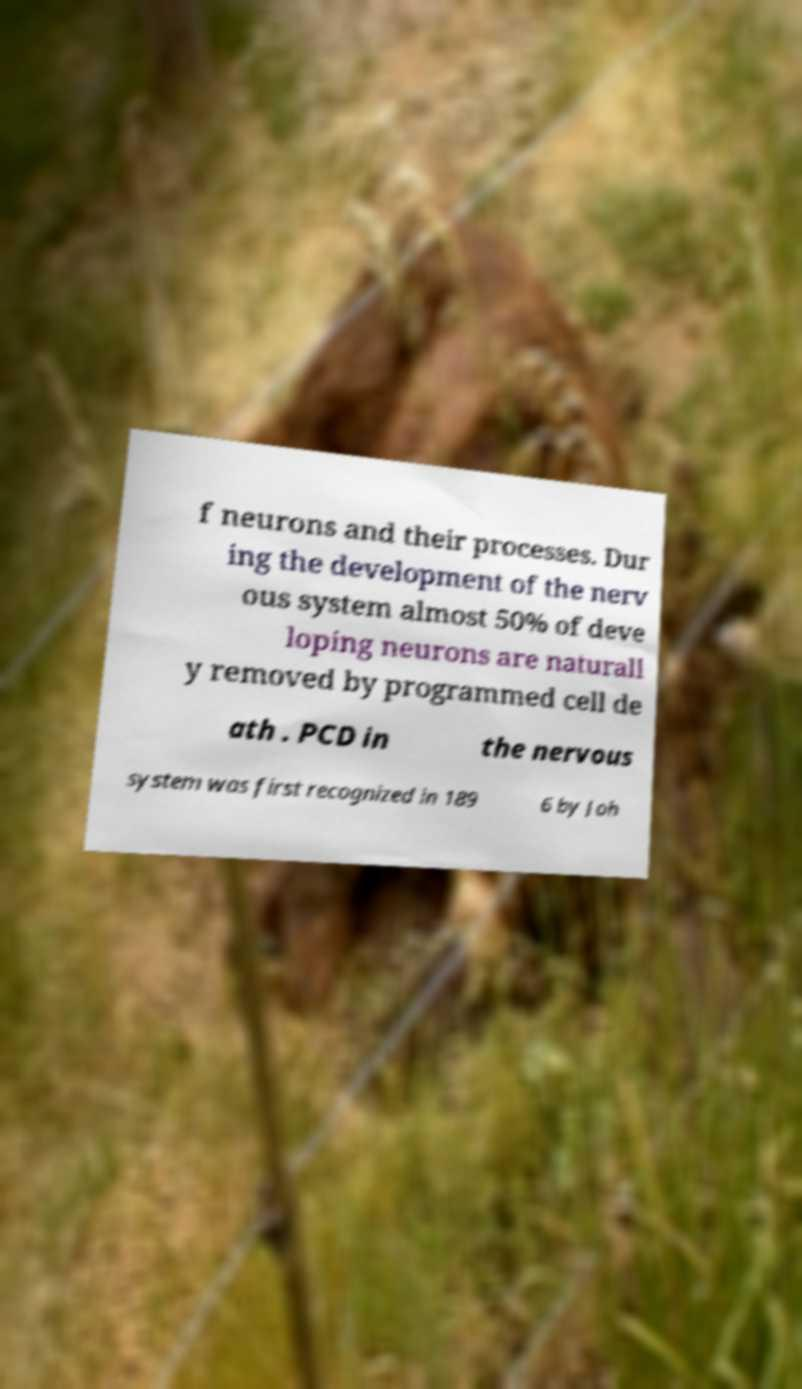What messages or text are displayed in this image? I need them in a readable, typed format. f neurons and their processes. Dur ing the development of the nerv ous system almost 50% of deve loping neurons are naturall y removed by programmed cell de ath . PCD in the nervous system was first recognized in 189 6 by Joh 